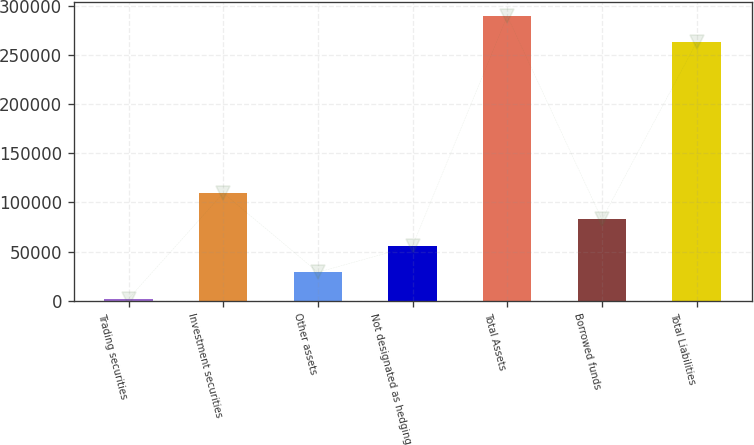<chart> <loc_0><loc_0><loc_500><loc_500><bar_chart><fcel>Trading securities<fcel>Investment securities<fcel>Other assets<fcel>Not designated as hedging<fcel>Total Assets<fcel>Borrowed funds<fcel>Total Liabilities<nl><fcel>2096<fcel>109506<fcel>28948.5<fcel>55801<fcel>289420<fcel>82653.5<fcel>262568<nl></chart> 